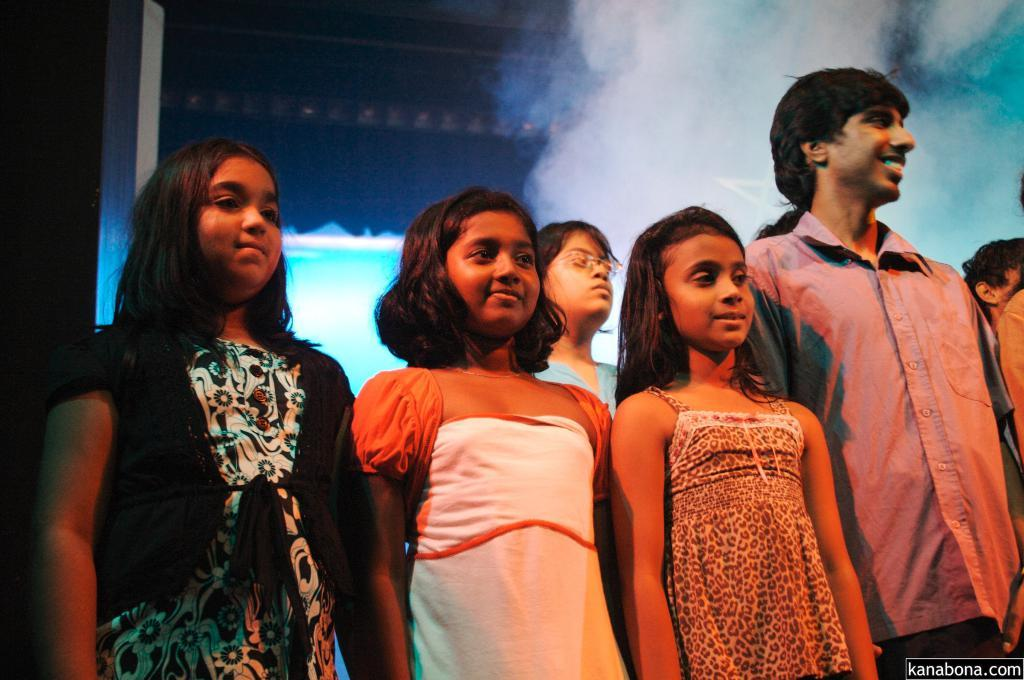What is the main subject of the image? The main subject of the image is a group of children. Can you describe the position of the children in the image? The children are standing in the center of the image. What can be seen in the background of the image? There is fog and a wall in the background of the image. What type of brass instrument is being played by the squirrel in the image? There is no squirrel or brass instrument present in the image. What is the children eating for lunch in the image? The image does not show the children eating lunch, so it cannot be determined from the image. 